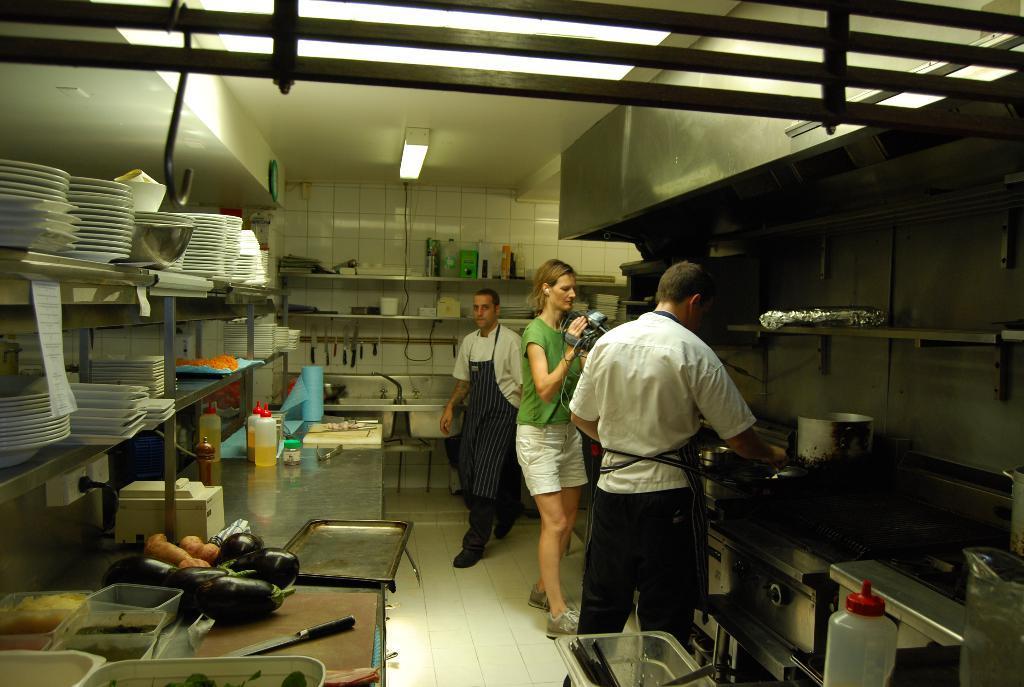Can you describe this image briefly? In the image we can see there three people standing, they are wearing clothes and shoes. This person is holding a video camera in hand, these are the vegetables, knife, box, plate, bottle, light, cable wire and the kitchen stuff. 